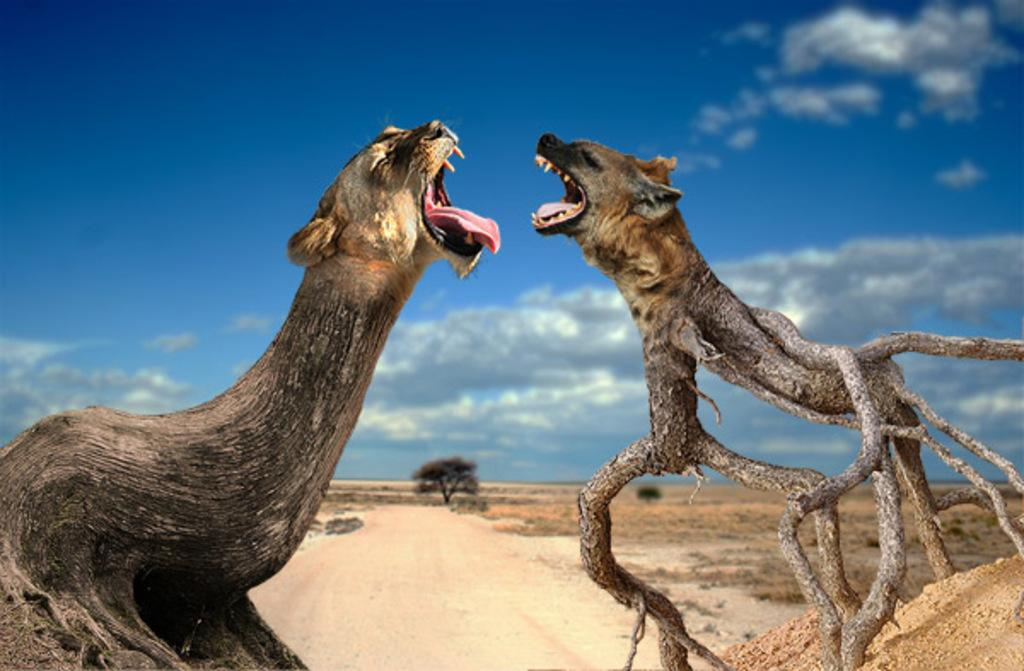What type of images are present in the image? There are edited pictures of animals in the image. What natural elements can be seen in the image? There are branches of trees and a tree visible in the image. What type of terrain is visible in the image? There is land visible in the image. What part of the natural environment is visible in the image? The sky is visible at the top of the image. Where is the son's house located in the image? There is no son or house present in the image; it features edited pictures of animals and natural elements. Can you tell me how many faucets are visible in the image? There are no faucets visible in the image. 